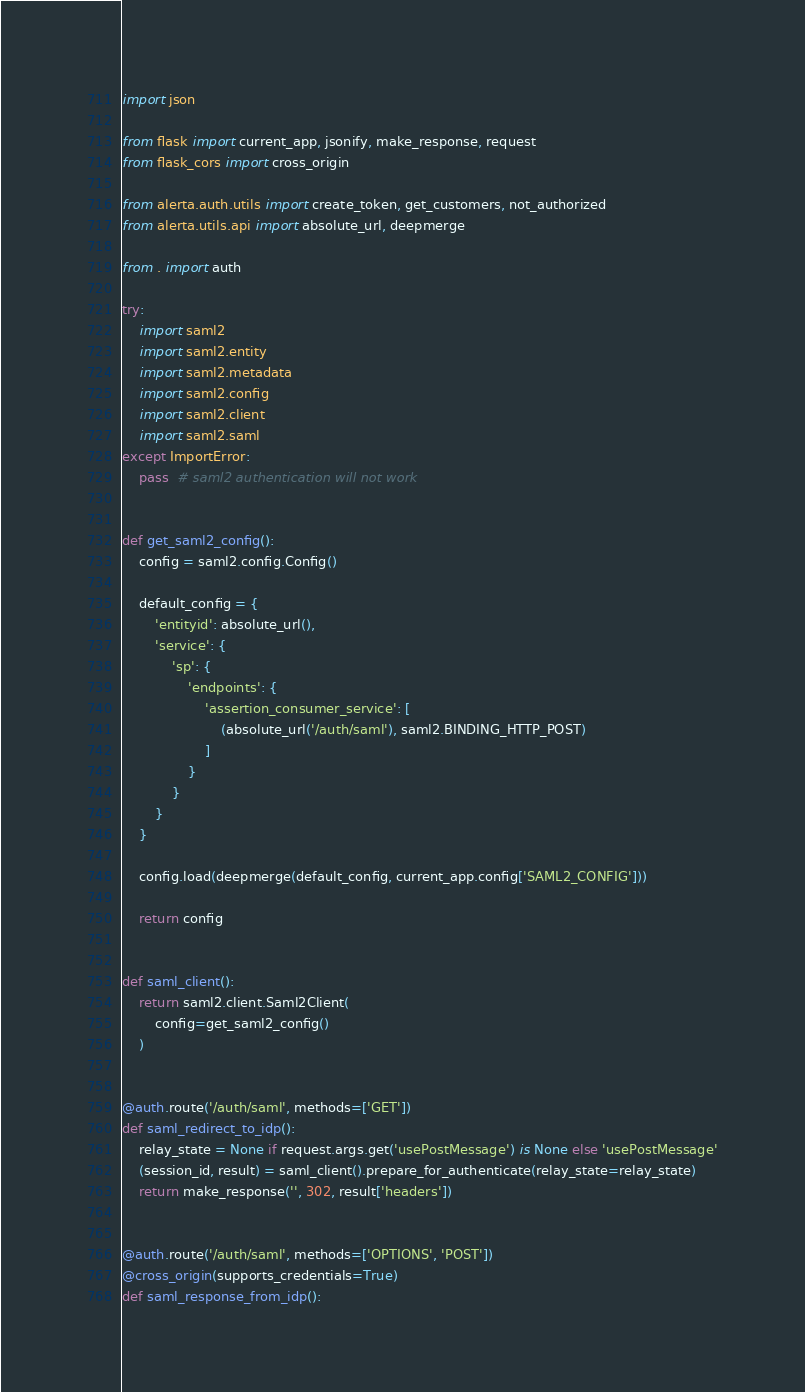Convert code to text. <code><loc_0><loc_0><loc_500><loc_500><_Python_>
import json

from flask import current_app, jsonify, make_response, request
from flask_cors import cross_origin

from alerta.auth.utils import create_token, get_customers, not_authorized
from alerta.utils.api import absolute_url, deepmerge

from . import auth

try:
    import saml2
    import saml2.entity
    import saml2.metadata
    import saml2.config
    import saml2.client
    import saml2.saml
except ImportError:
    pass  # saml2 authentication will not work


def get_saml2_config():
    config = saml2.config.Config()

    default_config = {
        'entityid': absolute_url(),
        'service': {
            'sp': {
                'endpoints': {
                    'assertion_consumer_service': [
                        (absolute_url('/auth/saml'), saml2.BINDING_HTTP_POST)
                    ]
                }
            }
        }
    }

    config.load(deepmerge(default_config, current_app.config['SAML2_CONFIG']))

    return config


def saml_client():
    return saml2.client.Saml2Client(
        config=get_saml2_config()
    )


@auth.route('/auth/saml', methods=['GET'])
def saml_redirect_to_idp():
    relay_state = None if request.args.get('usePostMessage') is None else 'usePostMessage'
    (session_id, result) = saml_client().prepare_for_authenticate(relay_state=relay_state)
    return make_response('', 302, result['headers'])


@auth.route('/auth/saml', methods=['OPTIONS', 'POST'])
@cross_origin(supports_credentials=True)
def saml_response_from_idp():</code> 